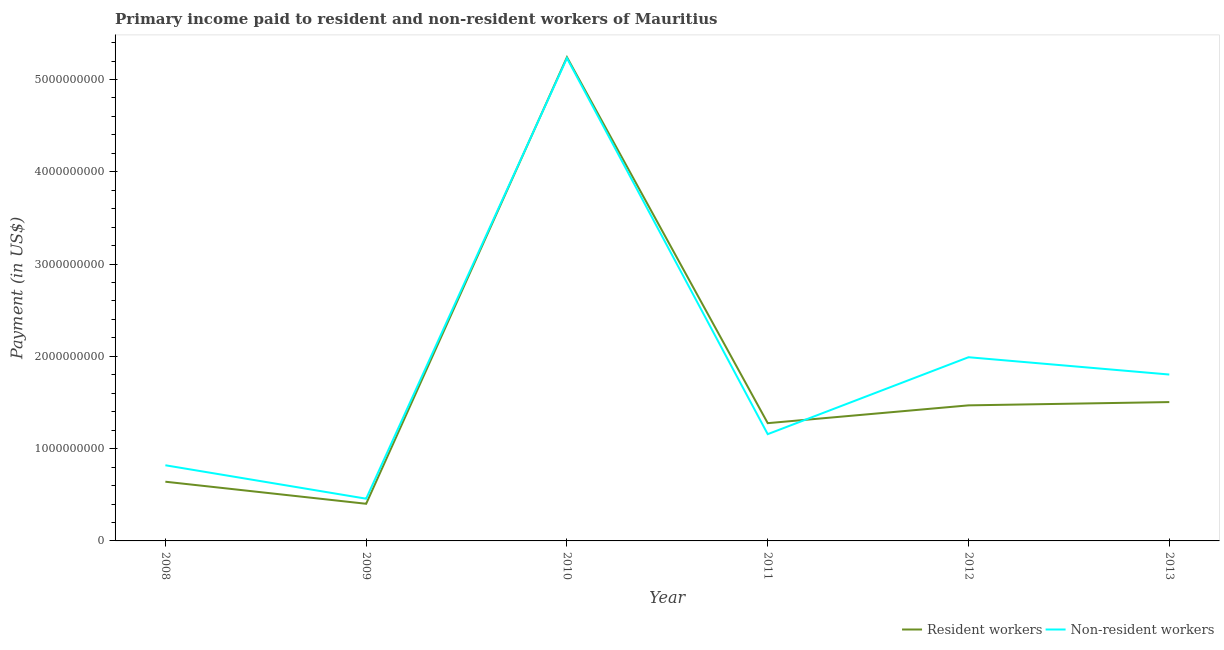How many different coloured lines are there?
Offer a terse response. 2. Does the line corresponding to payment made to resident workers intersect with the line corresponding to payment made to non-resident workers?
Your answer should be compact. Yes. Is the number of lines equal to the number of legend labels?
Your answer should be very brief. Yes. What is the payment made to resident workers in 2012?
Your response must be concise. 1.47e+09. Across all years, what is the maximum payment made to non-resident workers?
Provide a short and direct response. 5.23e+09. Across all years, what is the minimum payment made to resident workers?
Your answer should be compact. 4.03e+08. In which year was the payment made to non-resident workers minimum?
Your answer should be very brief. 2009. What is the total payment made to resident workers in the graph?
Ensure brevity in your answer.  1.05e+1. What is the difference between the payment made to resident workers in 2009 and that in 2012?
Your response must be concise. -1.07e+09. What is the difference between the payment made to resident workers in 2012 and the payment made to non-resident workers in 2010?
Your answer should be very brief. -3.76e+09. What is the average payment made to non-resident workers per year?
Your response must be concise. 1.91e+09. In the year 2013, what is the difference between the payment made to non-resident workers and payment made to resident workers?
Ensure brevity in your answer.  2.99e+08. In how many years, is the payment made to non-resident workers greater than 5200000000 US$?
Offer a very short reply. 1. What is the ratio of the payment made to non-resident workers in 2008 to that in 2010?
Provide a succinct answer. 0.16. Is the payment made to non-resident workers in 2009 less than that in 2012?
Your answer should be compact. Yes. Is the difference between the payment made to non-resident workers in 2008 and 2013 greater than the difference between the payment made to resident workers in 2008 and 2013?
Offer a very short reply. No. What is the difference between the highest and the second highest payment made to non-resident workers?
Your response must be concise. 3.24e+09. What is the difference between the highest and the lowest payment made to non-resident workers?
Your response must be concise. 4.77e+09. In how many years, is the payment made to non-resident workers greater than the average payment made to non-resident workers taken over all years?
Give a very brief answer. 2. Is the payment made to resident workers strictly greater than the payment made to non-resident workers over the years?
Offer a terse response. No. How many lines are there?
Your answer should be compact. 2. Are the values on the major ticks of Y-axis written in scientific E-notation?
Offer a terse response. No. Does the graph contain any zero values?
Your answer should be very brief. No. Where does the legend appear in the graph?
Ensure brevity in your answer.  Bottom right. How many legend labels are there?
Ensure brevity in your answer.  2. What is the title of the graph?
Your answer should be very brief. Primary income paid to resident and non-resident workers of Mauritius. Does "Age 65(female)" appear as one of the legend labels in the graph?
Make the answer very short. No. What is the label or title of the X-axis?
Provide a short and direct response. Year. What is the label or title of the Y-axis?
Provide a short and direct response. Payment (in US$). What is the Payment (in US$) in Resident workers in 2008?
Your response must be concise. 6.42e+08. What is the Payment (in US$) of Non-resident workers in 2008?
Your answer should be compact. 8.20e+08. What is the Payment (in US$) in Resident workers in 2009?
Offer a terse response. 4.03e+08. What is the Payment (in US$) of Non-resident workers in 2009?
Offer a very short reply. 4.58e+08. What is the Payment (in US$) of Resident workers in 2010?
Provide a succinct answer. 5.24e+09. What is the Payment (in US$) of Non-resident workers in 2010?
Keep it short and to the point. 5.23e+09. What is the Payment (in US$) in Resident workers in 2011?
Give a very brief answer. 1.28e+09. What is the Payment (in US$) in Non-resident workers in 2011?
Your response must be concise. 1.16e+09. What is the Payment (in US$) in Resident workers in 2012?
Provide a succinct answer. 1.47e+09. What is the Payment (in US$) in Non-resident workers in 2012?
Offer a terse response. 1.99e+09. What is the Payment (in US$) in Resident workers in 2013?
Give a very brief answer. 1.50e+09. What is the Payment (in US$) of Non-resident workers in 2013?
Your response must be concise. 1.80e+09. Across all years, what is the maximum Payment (in US$) in Resident workers?
Give a very brief answer. 5.24e+09. Across all years, what is the maximum Payment (in US$) of Non-resident workers?
Your answer should be compact. 5.23e+09. Across all years, what is the minimum Payment (in US$) of Resident workers?
Your answer should be compact. 4.03e+08. Across all years, what is the minimum Payment (in US$) of Non-resident workers?
Provide a succinct answer. 4.58e+08. What is the total Payment (in US$) in Resident workers in the graph?
Offer a very short reply. 1.05e+1. What is the total Payment (in US$) of Non-resident workers in the graph?
Keep it short and to the point. 1.15e+1. What is the difference between the Payment (in US$) in Resident workers in 2008 and that in 2009?
Offer a terse response. 2.39e+08. What is the difference between the Payment (in US$) of Non-resident workers in 2008 and that in 2009?
Keep it short and to the point. 3.62e+08. What is the difference between the Payment (in US$) of Resident workers in 2008 and that in 2010?
Keep it short and to the point. -4.60e+09. What is the difference between the Payment (in US$) of Non-resident workers in 2008 and that in 2010?
Provide a short and direct response. -4.41e+09. What is the difference between the Payment (in US$) of Resident workers in 2008 and that in 2011?
Offer a terse response. -6.34e+08. What is the difference between the Payment (in US$) in Non-resident workers in 2008 and that in 2011?
Offer a very short reply. -3.37e+08. What is the difference between the Payment (in US$) of Resident workers in 2008 and that in 2012?
Offer a terse response. -8.27e+08. What is the difference between the Payment (in US$) in Non-resident workers in 2008 and that in 2012?
Give a very brief answer. -1.17e+09. What is the difference between the Payment (in US$) of Resident workers in 2008 and that in 2013?
Your answer should be compact. -8.63e+08. What is the difference between the Payment (in US$) of Non-resident workers in 2008 and that in 2013?
Offer a very short reply. -9.83e+08. What is the difference between the Payment (in US$) of Resident workers in 2009 and that in 2010?
Keep it short and to the point. -4.84e+09. What is the difference between the Payment (in US$) in Non-resident workers in 2009 and that in 2010?
Give a very brief answer. -4.77e+09. What is the difference between the Payment (in US$) in Resident workers in 2009 and that in 2011?
Offer a terse response. -8.74e+08. What is the difference between the Payment (in US$) of Non-resident workers in 2009 and that in 2011?
Keep it short and to the point. -6.99e+08. What is the difference between the Payment (in US$) of Resident workers in 2009 and that in 2012?
Offer a terse response. -1.07e+09. What is the difference between the Payment (in US$) of Non-resident workers in 2009 and that in 2012?
Provide a succinct answer. -1.53e+09. What is the difference between the Payment (in US$) of Resident workers in 2009 and that in 2013?
Your answer should be compact. -1.10e+09. What is the difference between the Payment (in US$) of Non-resident workers in 2009 and that in 2013?
Give a very brief answer. -1.35e+09. What is the difference between the Payment (in US$) in Resident workers in 2010 and that in 2011?
Offer a very short reply. 3.97e+09. What is the difference between the Payment (in US$) in Non-resident workers in 2010 and that in 2011?
Provide a succinct answer. 4.07e+09. What is the difference between the Payment (in US$) in Resident workers in 2010 and that in 2012?
Keep it short and to the point. 3.77e+09. What is the difference between the Payment (in US$) in Non-resident workers in 2010 and that in 2012?
Offer a very short reply. 3.24e+09. What is the difference between the Payment (in US$) in Resident workers in 2010 and that in 2013?
Provide a succinct answer. 3.74e+09. What is the difference between the Payment (in US$) in Non-resident workers in 2010 and that in 2013?
Keep it short and to the point. 3.43e+09. What is the difference between the Payment (in US$) in Resident workers in 2011 and that in 2012?
Make the answer very short. -1.93e+08. What is the difference between the Payment (in US$) of Non-resident workers in 2011 and that in 2012?
Provide a short and direct response. -8.34e+08. What is the difference between the Payment (in US$) of Resident workers in 2011 and that in 2013?
Provide a succinct answer. -2.28e+08. What is the difference between the Payment (in US$) in Non-resident workers in 2011 and that in 2013?
Offer a very short reply. -6.46e+08. What is the difference between the Payment (in US$) in Resident workers in 2012 and that in 2013?
Provide a succinct answer. -3.55e+07. What is the difference between the Payment (in US$) of Non-resident workers in 2012 and that in 2013?
Keep it short and to the point. 1.88e+08. What is the difference between the Payment (in US$) of Resident workers in 2008 and the Payment (in US$) of Non-resident workers in 2009?
Ensure brevity in your answer.  1.84e+08. What is the difference between the Payment (in US$) of Resident workers in 2008 and the Payment (in US$) of Non-resident workers in 2010?
Give a very brief answer. -4.59e+09. What is the difference between the Payment (in US$) of Resident workers in 2008 and the Payment (in US$) of Non-resident workers in 2011?
Provide a succinct answer. -5.15e+08. What is the difference between the Payment (in US$) of Resident workers in 2008 and the Payment (in US$) of Non-resident workers in 2012?
Keep it short and to the point. -1.35e+09. What is the difference between the Payment (in US$) in Resident workers in 2008 and the Payment (in US$) in Non-resident workers in 2013?
Offer a very short reply. -1.16e+09. What is the difference between the Payment (in US$) in Resident workers in 2009 and the Payment (in US$) in Non-resident workers in 2010?
Provide a succinct answer. -4.83e+09. What is the difference between the Payment (in US$) of Resident workers in 2009 and the Payment (in US$) of Non-resident workers in 2011?
Your response must be concise. -7.54e+08. What is the difference between the Payment (in US$) in Resident workers in 2009 and the Payment (in US$) in Non-resident workers in 2012?
Your response must be concise. -1.59e+09. What is the difference between the Payment (in US$) in Resident workers in 2009 and the Payment (in US$) in Non-resident workers in 2013?
Your response must be concise. -1.40e+09. What is the difference between the Payment (in US$) in Resident workers in 2010 and the Payment (in US$) in Non-resident workers in 2011?
Provide a succinct answer. 4.08e+09. What is the difference between the Payment (in US$) in Resident workers in 2010 and the Payment (in US$) in Non-resident workers in 2012?
Keep it short and to the point. 3.25e+09. What is the difference between the Payment (in US$) of Resident workers in 2010 and the Payment (in US$) of Non-resident workers in 2013?
Provide a succinct answer. 3.44e+09. What is the difference between the Payment (in US$) of Resident workers in 2011 and the Payment (in US$) of Non-resident workers in 2012?
Ensure brevity in your answer.  -7.15e+08. What is the difference between the Payment (in US$) in Resident workers in 2011 and the Payment (in US$) in Non-resident workers in 2013?
Offer a very short reply. -5.27e+08. What is the difference between the Payment (in US$) in Resident workers in 2012 and the Payment (in US$) in Non-resident workers in 2013?
Your response must be concise. -3.34e+08. What is the average Payment (in US$) of Resident workers per year?
Provide a short and direct response. 1.76e+09. What is the average Payment (in US$) in Non-resident workers per year?
Provide a short and direct response. 1.91e+09. In the year 2008, what is the difference between the Payment (in US$) in Resident workers and Payment (in US$) in Non-resident workers?
Ensure brevity in your answer.  -1.78e+08. In the year 2009, what is the difference between the Payment (in US$) in Resident workers and Payment (in US$) in Non-resident workers?
Provide a succinct answer. -5.50e+07. In the year 2010, what is the difference between the Payment (in US$) in Resident workers and Payment (in US$) in Non-resident workers?
Make the answer very short. 1.00e+07. In the year 2011, what is the difference between the Payment (in US$) of Resident workers and Payment (in US$) of Non-resident workers?
Your answer should be very brief. 1.19e+08. In the year 2012, what is the difference between the Payment (in US$) of Resident workers and Payment (in US$) of Non-resident workers?
Offer a terse response. -5.22e+08. In the year 2013, what is the difference between the Payment (in US$) of Resident workers and Payment (in US$) of Non-resident workers?
Provide a short and direct response. -2.99e+08. What is the ratio of the Payment (in US$) in Resident workers in 2008 to that in 2009?
Offer a terse response. 1.59. What is the ratio of the Payment (in US$) of Non-resident workers in 2008 to that in 2009?
Offer a terse response. 1.79. What is the ratio of the Payment (in US$) of Resident workers in 2008 to that in 2010?
Make the answer very short. 0.12. What is the ratio of the Payment (in US$) in Non-resident workers in 2008 to that in 2010?
Provide a succinct answer. 0.16. What is the ratio of the Payment (in US$) of Resident workers in 2008 to that in 2011?
Provide a succinct answer. 0.5. What is the ratio of the Payment (in US$) in Non-resident workers in 2008 to that in 2011?
Keep it short and to the point. 0.71. What is the ratio of the Payment (in US$) in Resident workers in 2008 to that in 2012?
Provide a succinct answer. 0.44. What is the ratio of the Payment (in US$) in Non-resident workers in 2008 to that in 2012?
Give a very brief answer. 0.41. What is the ratio of the Payment (in US$) of Resident workers in 2008 to that in 2013?
Your answer should be compact. 0.43. What is the ratio of the Payment (in US$) of Non-resident workers in 2008 to that in 2013?
Keep it short and to the point. 0.45. What is the ratio of the Payment (in US$) of Resident workers in 2009 to that in 2010?
Give a very brief answer. 0.08. What is the ratio of the Payment (in US$) of Non-resident workers in 2009 to that in 2010?
Your response must be concise. 0.09. What is the ratio of the Payment (in US$) of Resident workers in 2009 to that in 2011?
Offer a very short reply. 0.32. What is the ratio of the Payment (in US$) in Non-resident workers in 2009 to that in 2011?
Ensure brevity in your answer.  0.4. What is the ratio of the Payment (in US$) in Resident workers in 2009 to that in 2012?
Provide a short and direct response. 0.27. What is the ratio of the Payment (in US$) of Non-resident workers in 2009 to that in 2012?
Your answer should be compact. 0.23. What is the ratio of the Payment (in US$) in Resident workers in 2009 to that in 2013?
Provide a short and direct response. 0.27. What is the ratio of the Payment (in US$) in Non-resident workers in 2009 to that in 2013?
Offer a very short reply. 0.25. What is the ratio of the Payment (in US$) of Resident workers in 2010 to that in 2011?
Your answer should be very brief. 4.11. What is the ratio of the Payment (in US$) of Non-resident workers in 2010 to that in 2011?
Make the answer very short. 4.52. What is the ratio of the Payment (in US$) in Resident workers in 2010 to that in 2012?
Make the answer very short. 3.57. What is the ratio of the Payment (in US$) of Non-resident workers in 2010 to that in 2012?
Provide a short and direct response. 2.63. What is the ratio of the Payment (in US$) in Resident workers in 2010 to that in 2013?
Your answer should be compact. 3.48. What is the ratio of the Payment (in US$) of Non-resident workers in 2010 to that in 2013?
Your response must be concise. 2.9. What is the ratio of the Payment (in US$) of Resident workers in 2011 to that in 2012?
Your response must be concise. 0.87. What is the ratio of the Payment (in US$) in Non-resident workers in 2011 to that in 2012?
Your answer should be very brief. 0.58. What is the ratio of the Payment (in US$) in Resident workers in 2011 to that in 2013?
Provide a short and direct response. 0.85. What is the ratio of the Payment (in US$) in Non-resident workers in 2011 to that in 2013?
Provide a succinct answer. 0.64. What is the ratio of the Payment (in US$) of Resident workers in 2012 to that in 2013?
Make the answer very short. 0.98. What is the ratio of the Payment (in US$) in Non-resident workers in 2012 to that in 2013?
Your answer should be very brief. 1.1. What is the difference between the highest and the second highest Payment (in US$) of Resident workers?
Offer a very short reply. 3.74e+09. What is the difference between the highest and the second highest Payment (in US$) in Non-resident workers?
Ensure brevity in your answer.  3.24e+09. What is the difference between the highest and the lowest Payment (in US$) of Resident workers?
Your response must be concise. 4.84e+09. What is the difference between the highest and the lowest Payment (in US$) in Non-resident workers?
Keep it short and to the point. 4.77e+09. 